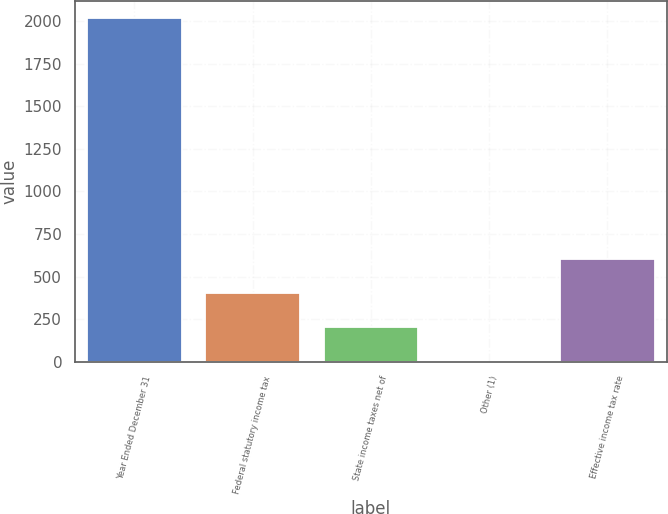Convert chart. <chart><loc_0><loc_0><loc_500><loc_500><bar_chart><fcel>Year Ended December 31<fcel>Federal statutory income tax<fcel>State income taxes net of<fcel>Other (1)<fcel>Effective income tax rate<nl><fcel>2015<fcel>403.88<fcel>202.49<fcel>1.1<fcel>605.27<nl></chart> 